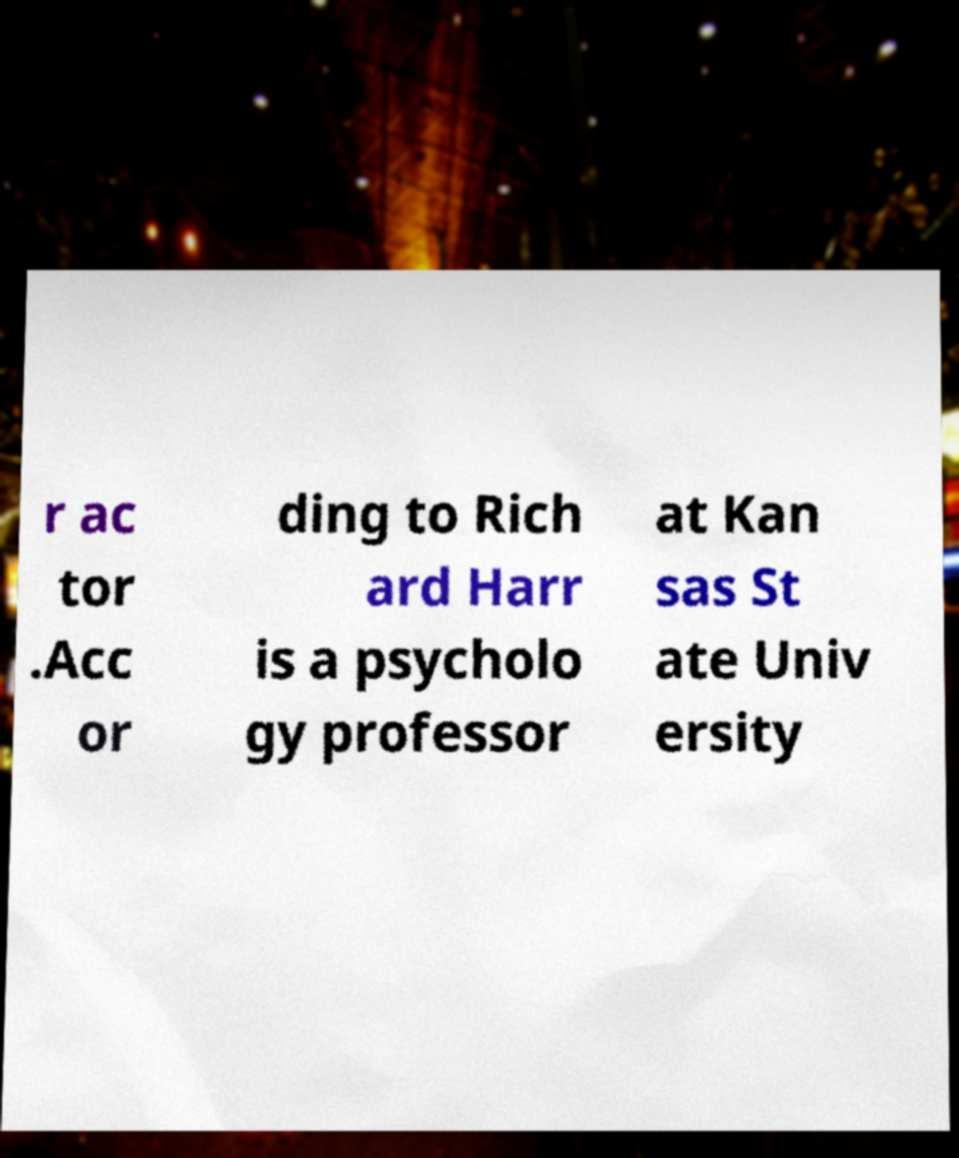What messages or text are displayed in this image? I need them in a readable, typed format. r ac tor .Acc or ding to Rich ard Harr is a psycholo gy professor at Kan sas St ate Univ ersity 